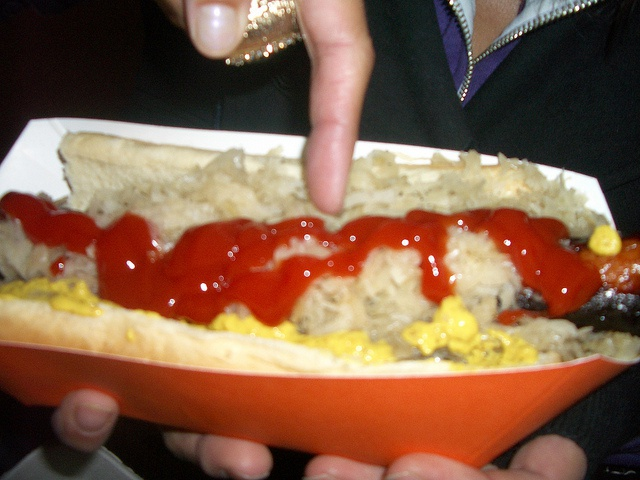Describe the objects in this image and their specific colors. I can see hot dog in black, tan, and maroon tones, people in black, brown, gray, and navy tones, and people in black, lightpink, gray, tan, and pink tones in this image. 